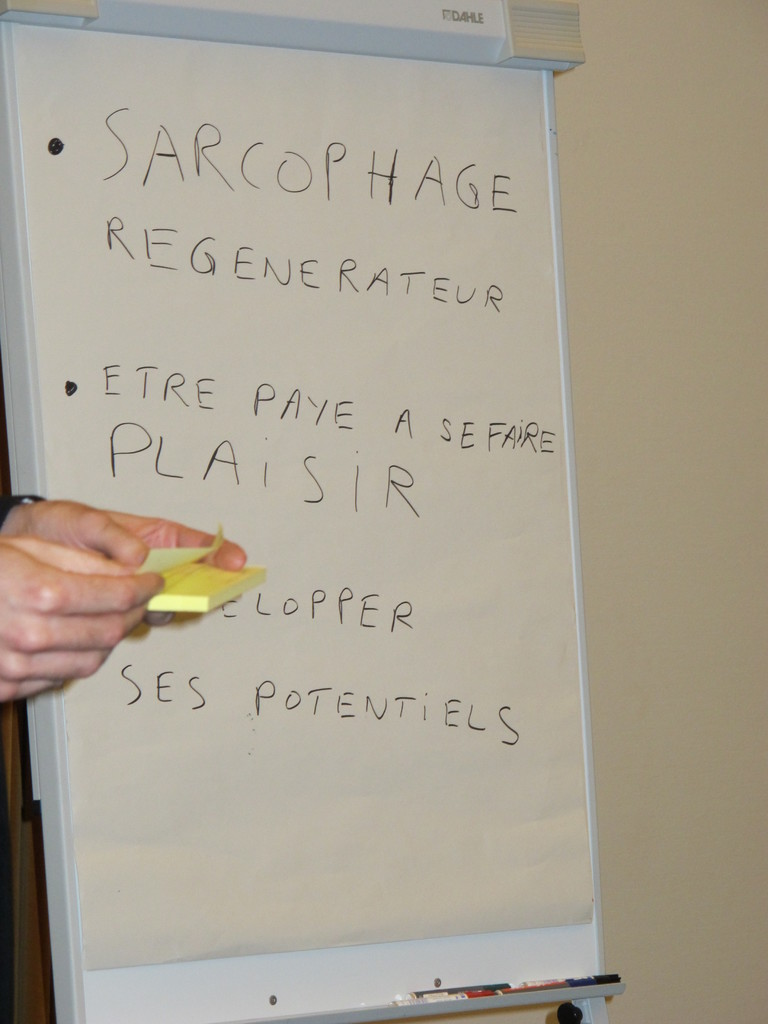What might 'SARCOPHAGE REGENERATEUR' suggest about the discussion in this meeting? 'SARCOPHAGE REGENERATEUR' suggests a highly creative or innovative theme being discussed, possibly relating to rejuvenation or revitalizing old ideas or systems, quite literally translating as "regenerating sarcophagus." It could imply a focus on transforming outdated methods or products in a rejuvenating manner. 